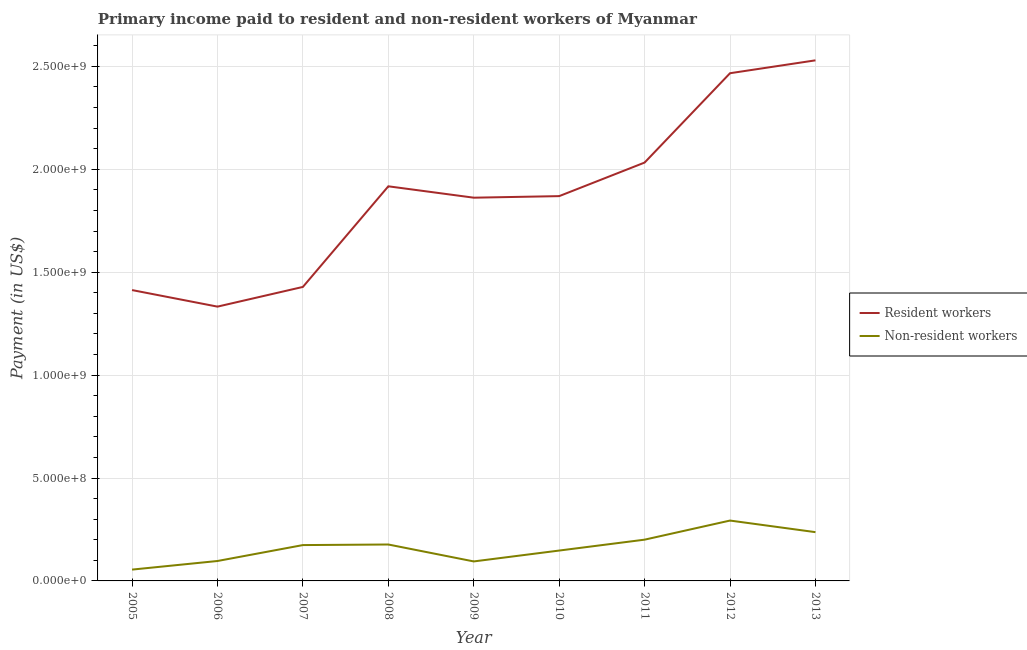What is the payment made to resident workers in 2009?
Your response must be concise. 1.86e+09. Across all years, what is the maximum payment made to resident workers?
Keep it short and to the point. 2.53e+09. Across all years, what is the minimum payment made to non-resident workers?
Make the answer very short. 5.50e+07. What is the total payment made to resident workers in the graph?
Make the answer very short. 1.69e+1. What is the difference between the payment made to non-resident workers in 2006 and that in 2011?
Provide a succinct answer. -1.04e+08. What is the difference between the payment made to non-resident workers in 2013 and the payment made to resident workers in 2010?
Offer a terse response. -1.63e+09. What is the average payment made to resident workers per year?
Offer a terse response. 1.87e+09. In the year 2012, what is the difference between the payment made to resident workers and payment made to non-resident workers?
Your answer should be very brief. 2.17e+09. What is the ratio of the payment made to resident workers in 2005 to that in 2013?
Keep it short and to the point. 0.56. Is the payment made to resident workers in 2005 less than that in 2006?
Keep it short and to the point. No. Is the difference between the payment made to resident workers in 2008 and 2012 greater than the difference between the payment made to non-resident workers in 2008 and 2012?
Make the answer very short. No. What is the difference between the highest and the second highest payment made to non-resident workers?
Your answer should be compact. 5.63e+07. What is the difference between the highest and the lowest payment made to resident workers?
Offer a terse response. 1.20e+09. In how many years, is the payment made to non-resident workers greater than the average payment made to non-resident workers taken over all years?
Ensure brevity in your answer.  5. Is the sum of the payment made to non-resident workers in 2005 and 2008 greater than the maximum payment made to resident workers across all years?
Ensure brevity in your answer.  No. Is the payment made to resident workers strictly greater than the payment made to non-resident workers over the years?
Your answer should be compact. Yes. Is the payment made to non-resident workers strictly less than the payment made to resident workers over the years?
Give a very brief answer. Yes. What is the difference between two consecutive major ticks on the Y-axis?
Make the answer very short. 5.00e+08. Does the graph contain any zero values?
Ensure brevity in your answer.  No. Where does the legend appear in the graph?
Ensure brevity in your answer.  Center right. How many legend labels are there?
Keep it short and to the point. 2. What is the title of the graph?
Offer a very short reply. Primary income paid to resident and non-resident workers of Myanmar. Does "Non-residents" appear as one of the legend labels in the graph?
Provide a succinct answer. No. What is the label or title of the Y-axis?
Give a very brief answer. Payment (in US$). What is the Payment (in US$) in Resident workers in 2005?
Give a very brief answer. 1.41e+09. What is the Payment (in US$) in Non-resident workers in 2005?
Your answer should be very brief. 5.50e+07. What is the Payment (in US$) of Resident workers in 2006?
Ensure brevity in your answer.  1.33e+09. What is the Payment (in US$) of Non-resident workers in 2006?
Your answer should be compact. 9.68e+07. What is the Payment (in US$) of Resident workers in 2007?
Provide a succinct answer. 1.43e+09. What is the Payment (in US$) of Non-resident workers in 2007?
Your answer should be compact. 1.74e+08. What is the Payment (in US$) of Resident workers in 2008?
Keep it short and to the point. 1.92e+09. What is the Payment (in US$) in Non-resident workers in 2008?
Your answer should be very brief. 1.77e+08. What is the Payment (in US$) in Resident workers in 2009?
Ensure brevity in your answer.  1.86e+09. What is the Payment (in US$) in Non-resident workers in 2009?
Make the answer very short. 9.47e+07. What is the Payment (in US$) in Resident workers in 2010?
Give a very brief answer. 1.87e+09. What is the Payment (in US$) of Non-resident workers in 2010?
Provide a short and direct response. 1.48e+08. What is the Payment (in US$) in Resident workers in 2011?
Offer a terse response. 2.03e+09. What is the Payment (in US$) in Non-resident workers in 2011?
Your response must be concise. 2.00e+08. What is the Payment (in US$) in Resident workers in 2012?
Ensure brevity in your answer.  2.47e+09. What is the Payment (in US$) of Non-resident workers in 2012?
Provide a short and direct response. 2.93e+08. What is the Payment (in US$) in Resident workers in 2013?
Offer a very short reply. 2.53e+09. What is the Payment (in US$) in Non-resident workers in 2013?
Your answer should be compact. 2.37e+08. Across all years, what is the maximum Payment (in US$) in Resident workers?
Keep it short and to the point. 2.53e+09. Across all years, what is the maximum Payment (in US$) of Non-resident workers?
Make the answer very short. 2.93e+08. Across all years, what is the minimum Payment (in US$) in Resident workers?
Your answer should be very brief. 1.33e+09. Across all years, what is the minimum Payment (in US$) of Non-resident workers?
Offer a terse response. 5.50e+07. What is the total Payment (in US$) of Resident workers in the graph?
Make the answer very short. 1.69e+1. What is the total Payment (in US$) of Non-resident workers in the graph?
Provide a short and direct response. 1.48e+09. What is the difference between the Payment (in US$) in Resident workers in 2005 and that in 2006?
Provide a succinct answer. 8.04e+07. What is the difference between the Payment (in US$) in Non-resident workers in 2005 and that in 2006?
Your answer should be compact. -4.18e+07. What is the difference between the Payment (in US$) of Resident workers in 2005 and that in 2007?
Offer a terse response. -1.53e+07. What is the difference between the Payment (in US$) of Non-resident workers in 2005 and that in 2007?
Keep it short and to the point. -1.19e+08. What is the difference between the Payment (in US$) in Resident workers in 2005 and that in 2008?
Your response must be concise. -5.04e+08. What is the difference between the Payment (in US$) in Non-resident workers in 2005 and that in 2008?
Give a very brief answer. -1.22e+08. What is the difference between the Payment (in US$) of Resident workers in 2005 and that in 2009?
Offer a very short reply. -4.49e+08. What is the difference between the Payment (in US$) of Non-resident workers in 2005 and that in 2009?
Give a very brief answer. -3.97e+07. What is the difference between the Payment (in US$) of Resident workers in 2005 and that in 2010?
Provide a succinct answer. -4.56e+08. What is the difference between the Payment (in US$) in Non-resident workers in 2005 and that in 2010?
Give a very brief answer. -9.25e+07. What is the difference between the Payment (in US$) of Resident workers in 2005 and that in 2011?
Offer a very short reply. -6.19e+08. What is the difference between the Payment (in US$) of Non-resident workers in 2005 and that in 2011?
Offer a terse response. -1.45e+08. What is the difference between the Payment (in US$) in Resident workers in 2005 and that in 2012?
Your answer should be compact. -1.05e+09. What is the difference between the Payment (in US$) in Non-resident workers in 2005 and that in 2012?
Provide a short and direct response. -2.38e+08. What is the difference between the Payment (in US$) of Resident workers in 2005 and that in 2013?
Your answer should be compact. -1.12e+09. What is the difference between the Payment (in US$) in Non-resident workers in 2005 and that in 2013?
Give a very brief answer. -1.82e+08. What is the difference between the Payment (in US$) of Resident workers in 2006 and that in 2007?
Provide a short and direct response. -9.57e+07. What is the difference between the Payment (in US$) of Non-resident workers in 2006 and that in 2007?
Your answer should be compact. -7.73e+07. What is the difference between the Payment (in US$) of Resident workers in 2006 and that in 2008?
Give a very brief answer. -5.85e+08. What is the difference between the Payment (in US$) in Non-resident workers in 2006 and that in 2008?
Ensure brevity in your answer.  -8.01e+07. What is the difference between the Payment (in US$) of Resident workers in 2006 and that in 2009?
Your answer should be very brief. -5.29e+08. What is the difference between the Payment (in US$) in Non-resident workers in 2006 and that in 2009?
Your answer should be compact. 2.09e+06. What is the difference between the Payment (in US$) in Resident workers in 2006 and that in 2010?
Your response must be concise. -5.37e+08. What is the difference between the Payment (in US$) of Non-resident workers in 2006 and that in 2010?
Ensure brevity in your answer.  -5.07e+07. What is the difference between the Payment (in US$) of Resident workers in 2006 and that in 2011?
Provide a short and direct response. -7.00e+08. What is the difference between the Payment (in US$) of Non-resident workers in 2006 and that in 2011?
Offer a very short reply. -1.04e+08. What is the difference between the Payment (in US$) in Resident workers in 2006 and that in 2012?
Your response must be concise. -1.13e+09. What is the difference between the Payment (in US$) in Non-resident workers in 2006 and that in 2012?
Offer a terse response. -1.96e+08. What is the difference between the Payment (in US$) in Resident workers in 2006 and that in 2013?
Provide a succinct answer. -1.20e+09. What is the difference between the Payment (in US$) in Non-resident workers in 2006 and that in 2013?
Give a very brief answer. -1.40e+08. What is the difference between the Payment (in US$) of Resident workers in 2007 and that in 2008?
Provide a short and direct response. -4.89e+08. What is the difference between the Payment (in US$) of Non-resident workers in 2007 and that in 2008?
Offer a terse response. -2.80e+06. What is the difference between the Payment (in US$) of Resident workers in 2007 and that in 2009?
Your response must be concise. -4.34e+08. What is the difference between the Payment (in US$) of Non-resident workers in 2007 and that in 2009?
Give a very brief answer. 7.94e+07. What is the difference between the Payment (in US$) of Resident workers in 2007 and that in 2010?
Provide a short and direct response. -4.41e+08. What is the difference between the Payment (in US$) of Non-resident workers in 2007 and that in 2010?
Provide a short and direct response. 2.66e+07. What is the difference between the Payment (in US$) of Resident workers in 2007 and that in 2011?
Give a very brief answer. -6.04e+08. What is the difference between the Payment (in US$) in Non-resident workers in 2007 and that in 2011?
Your response must be concise. -2.63e+07. What is the difference between the Payment (in US$) in Resident workers in 2007 and that in 2012?
Your answer should be compact. -1.04e+09. What is the difference between the Payment (in US$) in Non-resident workers in 2007 and that in 2012?
Offer a very short reply. -1.19e+08. What is the difference between the Payment (in US$) in Resident workers in 2007 and that in 2013?
Provide a short and direct response. -1.10e+09. What is the difference between the Payment (in US$) in Non-resident workers in 2007 and that in 2013?
Offer a very short reply. -6.28e+07. What is the difference between the Payment (in US$) of Resident workers in 2008 and that in 2009?
Offer a terse response. 5.53e+07. What is the difference between the Payment (in US$) in Non-resident workers in 2008 and that in 2009?
Your response must be concise. 8.22e+07. What is the difference between the Payment (in US$) in Resident workers in 2008 and that in 2010?
Offer a very short reply. 4.77e+07. What is the difference between the Payment (in US$) of Non-resident workers in 2008 and that in 2010?
Offer a very short reply. 2.94e+07. What is the difference between the Payment (in US$) of Resident workers in 2008 and that in 2011?
Offer a terse response. -1.15e+08. What is the difference between the Payment (in US$) in Non-resident workers in 2008 and that in 2011?
Your answer should be very brief. -2.35e+07. What is the difference between the Payment (in US$) of Resident workers in 2008 and that in 2012?
Your answer should be compact. -5.49e+08. What is the difference between the Payment (in US$) in Non-resident workers in 2008 and that in 2012?
Ensure brevity in your answer.  -1.16e+08. What is the difference between the Payment (in US$) in Resident workers in 2008 and that in 2013?
Keep it short and to the point. -6.12e+08. What is the difference between the Payment (in US$) in Non-resident workers in 2008 and that in 2013?
Give a very brief answer. -6.00e+07. What is the difference between the Payment (in US$) in Resident workers in 2009 and that in 2010?
Ensure brevity in your answer.  -7.55e+06. What is the difference between the Payment (in US$) in Non-resident workers in 2009 and that in 2010?
Keep it short and to the point. -5.28e+07. What is the difference between the Payment (in US$) in Resident workers in 2009 and that in 2011?
Provide a succinct answer. -1.71e+08. What is the difference between the Payment (in US$) in Non-resident workers in 2009 and that in 2011?
Your answer should be very brief. -1.06e+08. What is the difference between the Payment (in US$) of Resident workers in 2009 and that in 2012?
Provide a succinct answer. -6.05e+08. What is the difference between the Payment (in US$) in Non-resident workers in 2009 and that in 2012?
Provide a succinct answer. -1.99e+08. What is the difference between the Payment (in US$) of Resident workers in 2009 and that in 2013?
Give a very brief answer. -6.67e+08. What is the difference between the Payment (in US$) of Non-resident workers in 2009 and that in 2013?
Provide a short and direct response. -1.42e+08. What is the difference between the Payment (in US$) in Resident workers in 2010 and that in 2011?
Your answer should be compact. -1.63e+08. What is the difference between the Payment (in US$) of Non-resident workers in 2010 and that in 2011?
Provide a short and direct response. -5.29e+07. What is the difference between the Payment (in US$) in Resident workers in 2010 and that in 2012?
Offer a very short reply. -5.97e+08. What is the difference between the Payment (in US$) of Non-resident workers in 2010 and that in 2012?
Give a very brief answer. -1.46e+08. What is the difference between the Payment (in US$) in Resident workers in 2010 and that in 2013?
Give a very brief answer. -6.60e+08. What is the difference between the Payment (in US$) in Non-resident workers in 2010 and that in 2013?
Provide a short and direct response. -8.94e+07. What is the difference between the Payment (in US$) of Resident workers in 2011 and that in 2012?
Offer a terse response. -4.34e+08. What is the difference between the Payment (in US$) in Non-resident workers in 2011 and that in 2012?
Your response must be concise. -9.28e+07. What is the difference between the Payment (in US$) of Resident workers in 2011 and that in 2013?
Your answer should be very brief. -4.97e+08. What is the difference between the Payment (in US$) of Non-resident workers in 2011 and that in 2013?
Your answer should be compact. -3.65e+07. What is the difference between the Payment (in US$) of Resident workers in 2012 and that in 2013?
Keep it short and to the point. -6.26e+07. What is the difference between the Payment (in US$) of Non-resident workers in 2012 and that in 2013?
Give a very brief answer. 5.63e+07. What is the difference between the Payment (in US$) in Resident workers in 2005 and the Payment (in US$) in Non-resident workers in 2006?
Offer a terse response. 1.32e+09. What is the difference between the Payment (in US$) of Resident workers in 2005 and the Payment (in US$) of Non-resident workers in 2007?
Provide a short and direct response. 1.24e+09. What is the difference between the Payment (in US$) in Resident workers in 2005 and the Payment (in US$) in Non-resident workers in 2008?
Provide a succinct answer. 1.24e+09. What is the difference between the Payment (in US$) of Resident workers in 2005 and the Payment (in US$) of Non-resident workers in 2009?
Ensure brevity in your answer.  1.32e+09. What is the difference between the Payment (in US$) in Resident workers in 2005 and the Payment (in US$) in Non-resident workers in 2010?
Keep it short and to the point. 1.27e+09. What is the difference between the Payment (in US$) in Resident workers in 2005 and the Payment (in US$) in Non-resident workers in 2011?
Ensure brevity in your answer.  1.21e+09. What is the difference between the Payment (in US$) of Resident workers in 2005 and the Payment (in US$) of Non-resident workers in 2012?
Ensure brevity in your answer.  1.12e+09. What is the difference between the Payment (in US$) of Resident workers in 2005 and the Payment (in US$) of Non-resident workers in 2013?
Provide a succinct answer. 1.18e+09. What is the difference between the Payment (in US$) in Resident workers in 2006 and the Payment (in US$) in Non-resident workers in 2007?
Your answer should be compact. 1.16e+09. What is the difference between the Payment (in US$) of Resident workers in 2006 and the Payment (in US$) of Non-resident workers in 2008?
Offer a terse response. 1.16e+09. What is the difference between the Payment (in US$) of Resident workers in 2006 and the Payment (in US$) of Non-resident workers in 2009?
Keep it short and to the point. 1.24e+09. What is the difference between the Payment (in US$) in Resident workers in 2006 and the Payment (in US$) in Non-resident workers in 2010?
Offer a terse response. 1.19e+09. What is the difference between the Payment (in US$) of Resident workers in 2006 and the Payment (in US$) of Non-resident workers in 2011?
Provide a short and direct response. 1.13e+09. What is the difference between the Payment (in US$) in Resident workers in 2006 and the Payment (in US$) in Non-resident workers in 2012?
Provide a succinct answer. 1.04e+09. What is the difference between the Payment (in US$) of Resident workers in 2006 and the Payment (in US$) of Non-resident workers in 2013?
Ensure brevity in your answer.  1.10e+09. What is the difference between the Payment (in US$) in Resident workers in 2007 and the Payment (in US$) in Non-resident workers in 2008?
Provide a short and direct response. 1.25e+09. What is the difference between the Payment (in US$) in Resident workers in 2007 and the Payment (in US$) in Non-resident workers in 2009?
Give a very brief answer. 1.33e+09. What is the difference between the Payment (in US$) of Resident workers in 2007 and the Payment (in US$) of Non-resident workers in 2010?
Keep it short and to the point. 1.28e+09. What is the difference between the Payment (in US$) of Resident workers in 2007 and the Payment (in US$) of Non-resident workers in 2011?
Provide a short and direct response. 1.23e+09. What is the difference between the Payment (in US$) of Resident workers in 2007 and the Payment (in US$) of Non-resident workers in 2012?
Make the answer very short. 1.14e+09. What is the difference between the Payment (in US$) in Resident workers in 2007 and the Payment (in US$) in Non-resident workers in 2013?
Give a very brief answer. 1.19e+09. What is the difference between the Payment (in US$) in Resident workers in 2008 and the Payment (in US$) in Non-resident workers in 2009?
Make the answer very short. 1.82e+09. What is the difference between the Payment (in US$) of Resident workers in 2008 and the Payment (in US$) of Non-resident workers in 2010?
Offer a very short reply. 1.77e+09. What is the difference between the Payment (in US$) of Resident workers in 2008 and the Payment (in US$) of Non-resident workers in 2011?
Provide a succinct answer. 1.72e+09. What is the difference between the Payment (in US$) in Resident workers in 2008 and the Payment (in US$) in Non-resident workers in 2012?
Your answer should be compact. 1.62e+09. What is the difference between the Payment (in US$) of Resident workers in 2008 and the Payment (in US$) of Non-resident workers in 2013?
Provide a short and direct response. 1.68e+09. What is the difference between the Payment (in US$) of Resident workers in 2009 and the Payment (in US$) of Non-resident workers in 2010?
Keep it short and to the point. 1.71e+09. What is the difference between the Payment (in US$) in Resident workers in 2009 and the Payment (in US$) in Non-resident workers in 2011?
Offer a very short reply. 1.66e+09. What is the difference between the Payment (in US$) in Resident workers in 2009 and the Payment (in US$) in Non-resident workers in 2012?
Make the answer very short. 1.57e+09. What is the difference between the Payment (in US$) in Resident workers in 2009 and the Payment (in US$) in Non-resident workers in 2013?
Make the answer very short. 1.62e+09. What is the difference between the Payment (in US$) of Resident workers in 2010 and the Payment (in US$) of Non-resident workers in 2011?
Your answer should be compact. 1.67e+09. What is the difference between the Payment (in US$) of Resident workers in 2010 and the Payment (in US$) of Non-resident workers in 2012?
Provide a short and direct response. 1.58e+09. What is the difference between the Payment (in US$) of Resident workers in 2010 and the Payment (in US$) of Non-resident workers in 2013?
Your response must be concise. 1.63e+09. What is the difference between the Payment (in US$) in Resident workers in 2011 and the Payment (in US$) in Non-resident workers in 2012?
Offer a terse response. 1.74e+09. What is the difference between the Payment (in US$) in Resident workers in 2011 and the Payment (in US$) in Non-resident workers in 2013?
Your response must be concise. 1.80e+09. What is the difference between the Payment (in US$) of Resident workers in 2012 and the Payment (in US$) of Non-resident workers in 2013?
Your answer should be compact. 2.23e+09. What is the average Payment (in US$) in Resident workers per year?
Keep it short and to the point. 1.87e+09. What is the average Payment (in US$) of Non-resident workers per year?
Your answer should be compact. 1.64e+08. In the year 2005, what is the difference between the Payment (in US$) of Resident workers and Payment (in US$) of Non-resident workers?
Provide a succinct answer. 1.36e+09. In the year 2006, what is the difference between the Payment (in US$) in Resident workers and Payment (in US$) in Non-resident workers?
Provide a succinct answer. 1.24e+09. In the year 2007, what is the difference between the Payment (in US$) of Resident workers and Payment (in US$) of Non-resident workers?
Provide a succinct answer. 1.25e+09. In the year 2008, what is the difference between the Payment (in US$) of Resident workers and Payment (in US$) of Non-resident workers?
Your answer should be compact. 1.74e+09. In the year 2009, what is the difference between the Payment (in US$) of Resident workers and Payment (in US$) of Non-resident workers?
Keep it short and to the point. 1.77e+09. In the year 2010, what is the difference between the Payment (in US$) in Resident workers and Payment (in US$) in Non-resident workers?
Offer a terse response. 1.72e+09. In the year 2011, what is the difference between the Payment (in US$) in Resident workers and Payment (in US$) in Non-resident workers?
Ensure brevity in your answer.  1.83e+09. In the year 2012, what is the difference between the Payment (in US$) of Resident workers and Payment (in US$) of Non-resident workers?
Give a very brief answer. 2.17e+09. In the year 2013, what is the difference between the Payment (in US$) of Resident workers and Payment (in US$) of Non-resident workers?
Provide a succinct answer. 2.29e+09. What is the ratio of the Payment (in US$) in Resident workers in 2005 to that in 2006?
Ensure brevity in your answer.  1.06. What is the ratio of the Payment (in US$) of Non-resident workers in 2005 to that in 2006?
Your answer should be very brief. 0.57. What is the ratio of the Payment (in US$) in Resident workers in 2005 to that in 2007?
Your answer should be compact. 0.99. What is the ratio of the Payment (in US$) of Non-resident workers in 2005 to that in 2007?
Provide a succinct answer. 0.32. What is the ratio of the Payment (in US$) of Resident workers in 2005 to that in 2008?
Your response must be concise. 0.74. What is the ratio of the Payment (in US$) of Non-resident workers in 2005 to that in 2008?
Provide a short and direct response. 0.31. What is the ratio of the Payment (in US$) in Resident workers in 2005 to that in 2009?
Make the answer very short. 0.76. What is the ratio of the Payment (in US$) of Non-resident workers in 2005 to that in 2009?
Your answer should be very brief. 0.58. What is the ratio of the Payment (in US$) in Resident workers in 2005 to that in 2010?
Keep it short and to the point. 0.76. What is the ratio of the Payment (in US$) of Non-resident workers in 2005 to that in 2010?
Offer a terse response. 0.37. What is the ratio of the Payment (in US$) in Resident workers in 2005 to that in 2011?
Your answer should be very brief. 0.7. What is the ratio of the Payment (in US$) of Non-resident workers in 2005 to that in 2011?
Provide a succinct answer. 0.27. What is the ratio of the Payment (in US$) in Resident workers in 2005 to that in 2012?
Your answer should be compact. 0.57. What is the ratio of the Payment (in US$) of Non-resident workers in 2005 to that in 2012?
Offer a terse response. 0.19. What is the ratio of the Payment (in US$) of Resident workers in 2005 to that in 2013?
Offer a terse response. 0.56. What is the ratio of the Payment (in US$) in Non-resident workers in 2005 to that in 2013?
Ensure brevity in your answer.  0.23. What is the ratio of the Payment (in US$) of Resident workers in 2006 to that in 2007?
Your response must be concise. 0.93. What is the ratio of the Payment (in US$) of Non-resident workers in 2006 to that in 2007?
Make the answer very short. 0.56. What is the ratio of the Payment (in US$) in Resident workers in 2006 to that in 2008?
Provide a short and direct response. 0.7. What is the ratio of the Payment (in US$) of Non-resident workers in 2006 to that in 2008?
Ensure brevity in your answer.  0.55. What is the ratio of the Payment (in US$) of Resident workers in 2006 to that in 2009?
Your answer should be compact. 0.72. What is the ratio of the Payment (in US$) in Non-resident workers in 2006 to that in 2009?
Give a very brief answer. 1.02. What is the ratio of the Payment (in US$) of Resident workers in 2006 to that in 2010?
Your response must be concise. 0.71. What is the ratio of the Payment (in US$) of Non-resident workers in 2006 to that in 2010?
Your response must be concise. 0.66. What is the ratio of the Payment (in US$) of Resident workers in 2006 to that in 2011?
Your answer should be very brief. 0.66. What is the ratio of the Payment (in US$) of Non-resident workers in 2006 to that in 2011?
Offer a very short reply. 0.48. What is the ratio of the Payment (in US$) in Resident workers in 2006 to that in 2012?
Your response must be concise. 0.54. What is the ratio of the Payment (in US$) of Non-resident workers in 2006 to that in 2012?
Your answer should be compact. 0.33. What is the ratio of the Payment (in US$) of Resident workers in 2006 to that in 2013?
Your response must be concise. 0.53. What is the ratio of the Payment (in US$) of Non-resident workers in 2006 to that in 2013?
Provide a short and direct response. 0.41. What is the ratio of the Payment (in US$) of Resident workers in 2007 to that in 2008?
Ensure brevity in your answer.  0.74. What is the ratio of the Payment (in US$) of Non-resident workers in 2007 to that in 2008?
Your answer should be very brief. 0.98. What is the ratio of the Payment (in US$) in Resident workers in 2007 to that in 2009?
Ensure brevity in your answer.  0.77. What is the ratio of the Payment (in US$) in Non-resident workers in 2007 to that in 2009?
Offer a terse response. 1.84. What is the ratio of the Payment (in US$) in Resident workers in 2007 to that in 2010?
Keep it short and to the point. 0.76. What is the ratio of the Payment (in US$) of Non-resident workers in 2007 to that in 2010?
Provide a succinct answer. 1.18. What is the ratio of the Payment (in US$) in Resident workers in 2007 to that in 2011?
Your answer should be compact. 0.7. What is the ratio of the Payment (in US$) in Non-resident workers in 2007 to that in 2011?
Offer a terse response. 0.87. What is the ratio of the Payment (in US$) of Resident workers in 2007 to that in 2012?
Your answer should be very brief. 0.58. What is the ratio of the Payment (in US$) in Non-resident workers in 2007 to that in 2012?
Provide a succinct answer. 0.59. What is the ratio of the Payment (in US$) in Resident workers in 2007 to that in 2013?
Your response must be concise. 0.56. What is the ratio of the Payment (in US$) in Non-resident workers in 2007 to that in 2013?
Offer a very short reply. 0.73. What is the ratio of the Payment (in US$) in Resident workers in 2008 to that in 2009?
Provide a short and direct response. 1.03. What is the ratio of the Payment (in US$) of Non-resident workers in 2008 to that in 2009?
Give a very brief answer. 1.87. What is the ratio of the Payment (in US$) in Resident workers in 2008 to that in 2010?
Offer a terse response. 1.03. What is the ratio of the Payment (in US$) in Non-resident workers in 2008 to that in 2010?
Keep it short and to the point. 1.2. What is the ratio of the Payment (in US$) of Resident workers in 2008 to that in 2011?
Your answer should be compact. 0.94. What is the ratio of the Payment (in US$) in Non-resident workers in 2008 to that in 2011?
Make the answer very short. 0.88. What is the ratio of the Payment (in US$) of Resident workers in 2008 to that in 2012?
Make the answer very short. 0.78. What is the ratio of the Payment (in US$) in Non-resident workers in 2008 to that in 2012?
Provide a succinct answer. 0.6. What is the ratio of the Payment (in US$) in Resident workers in 2008 to that in 2013?
Provide a succinct answer. 0.76. What is the ratio of the Payment (in US$) of Non-resident workers in 2008 to that in 2013?
Provide a short and direct response. 0.75. What is the ratio of the Payment (in US$) in Non-resident workers in 2009 to that in 2010?
Give a very brief answer. 0.64. What is the ratio of the Payment (in US$) of Resident workers in 2009 to that in 2011?
Provide a succinct answer. 0.92. What is the ratio of the Payment (in US$) in Non-resident workers in 2009 to that in 2011?
Give a very brief answer. 0.47. What is the ratio of the Payment (in US$) in Resident workers in 2009 to that in 2012?
Offer a very short reply. 0.75. What is the ratio of the Payment (in US$) of Non-resident workers in 2009 to that in 2012?
Your answer should be very brief. 0.32. What is the ratio of the Payment (in US$) in Resident workers in 2009 to that in 2013?
Ensure brevity in your answer.  0.74. What is the ratio of the Payment (in US$) in Non-resident workers in 2009 to that in 2013?
Your response must be concise. 0.4. What is the ratio of the Payment (in US$) of Resident workers in 2010 to that in 2011?
Make the answer very short. 0.92. What is the ratio of the Payment (in US$) in Non-resident workers in 2010 to that in 2011?
Offer a terse response. 0.74. What is the ratio of the Payment (in US$) of Resident workers in 2010 to that in 2012?
Provide a succinct answer. 0.76. What is the ratio of the Payment (in US$) of Non-resident workers in 2010 to that in 2012?
Your answer should be very brief. 0.5. What is the ratio of the Payment (in US$) in Resident workers in 2010 to that in 2013?
Your response must be concise. 0.74. What is the ratio of the Payment (in US$) in Non-resident workers in 2010 to that in 2013?
Provide a short and direct response. 0.62. What is the ratio of the Payment (in US$) of Resident workers in 2011 to that in 2012?
Make the answer very short. 0.82. What is the ratio of the Payment (in US$) of Non-resident workers in 2011 to that in 2012?
Your response must be concise. 0.68. What is the ratio of the Payment (in US$) in Resident workers in 2011 to that in 2013?
Make the answer very short. 0.8. What is the ratio of the Payment (in US$) of Non-resident workers in 2011 to that in 2013?
Keep it short and to the point. 0.85. What is the ratio of the Payment (in US$) of Resident workers in 2012 to that in 2013?
Ensure brevity in your answer.  0.98. What is the ratio of the Payment (in US$) in Non-resident workers in 2012 to that in 2013?
Provide a succinct answer. 1.24. What is the difference between the highest and the second highest Payment (in US$) of Resident workers?
Your answer should be very brief. 6.26e+07. What is the difference between the highest and the second highest Payment (in US$) of Non-resident workers?
Keep it short and to the point. 5.63e+07. What is the difference between the highest and the lowest Payment (in US$) of Resident workers?
Offer a very short reply. 1.20e+09. What is the difference between the highest and the lowest Payment (in US$) of Non-resident workers?
Make the answer very short. 2.38e+08. 